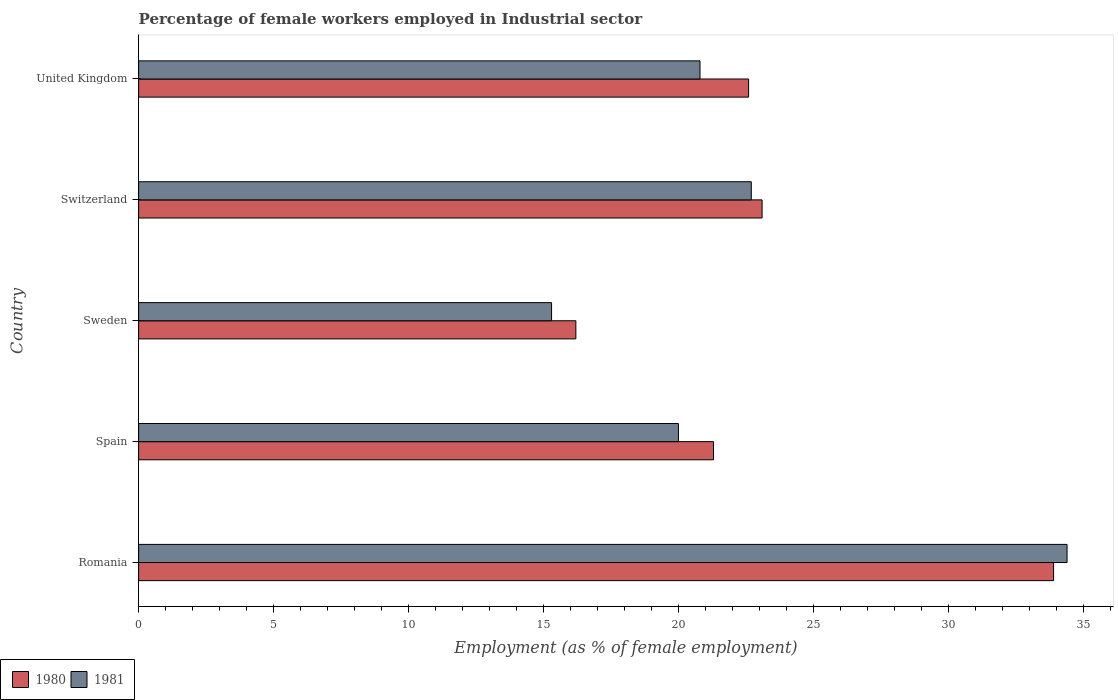Are the number of bars per tick equal to the number of legend labels?
Ensure brevity in your answer.  Yes. Are the number of bars on each tick of the Y-axis equal?
Offer a very short reply. Yes. How many bars are there on the 5th tick from the top?
Offer a terse response. 2. In how many cases, is the number of bars for a given country not equal to the number of legend labels?
Give a very brief answer. 0. What is the percentage of females employed in Industrial sector in 1981 in Romania?
Give a very brief answer. 34.4. Across all countries, what is the maximum percentage of females employed in Industrial sector in 1981?
Your answer should be very brief. 34.4. Across all countries, what is the minimum percentage of females employed in Industrial sector in 1981?
Offer a terse response. 15.3. In which country was the percentage of females employed in Industrial sector in 1980 maximum?
Ensure brevity in your answer.  Romania. What is the total percentage of females employed in Industrial sector in 1981 in the graph?
Your response must be concise. 113.2. What is the difference between the percentage of females employed in Industrial sector in 1981 in Sweden and that in United Kingdom?
Provide a succinct answer. -5.5. What is the difference between the percentage of females employed in Industrial sector in 1980 in Switzerland and the percentage of females employed in Industrial sector in 1981 in Spain?
Provide a short and direct response. 3.1. What is the average percentage of females employed in Industrial sector in 1980 per country?
Your response must be concise. 23.42. What is the difference between the percentage of females employed in Industrial sector in 1981 and percentage of females employed in Industrial sector in 1980 in Sweden?
Give a very brief answer. -0.9. In how many countries, is the percentage of females employed in Industrial sector in 1981 greater than 23 %?
Provide a succinct answer. 1. What is the ratio of the percentage of females employed in Industrial sector in 1981 in Romania to that in United Kingdom?
Make the answer very short. 1.65. Is the percentage of females employed in Industrial sector in 1980 in Sweden less than that in Switzerland?
Offer a very short reply. Yes. What is the difference between the highest and the second highest percentage of females employed in Industrial sector in 1981?
Offer a terse response. 11.7. What is the difference between the highest and the lowest percentage of females employed in Industrial sector in 1981?
Your response must be concise. 19.1. In how many countries, is the percentage of females employed in Industrial sector in 1980 greater than the average percentage of females employed in Industrial sector in 1980 taken over all countries?
Keep it short and to the point. 1. Is the sum of the percentage of females employed in Industrial sector in 1980 in Switzerland and United Kingdom greater than the maximum percentage of females employed in Industrial sector in 1981 across all countries?
Provide a short and direct response. Yes. How many bars are there?
Provide a short and direct response. 10. Are all the bars in the graph horizontal?
Your answer should be very brief. Yes. How many countries are there in the graph?
Your response must be concise. 5. Are the values on the major ticks of X-axis written in scientific E-notation?
Ensure brevity in your answer.  No. Does the graph contain any zero values?
Give a very brief answer. No. Where does the legend appear in the graph?
Offer a very short reply. Bottom left. How many legend labels are there?
Provide a succinct answer. 2. What is the title of the graph?
Provide a succinct answer. Percentage of female workers employed in Industrial sector. Does "1966" appear as one of the legend labels in the graph?
Make the answer very short. No. What is the label or title of the X-axis?
Your response must be concise. Employment (as % of female employment). What is the label or title of the Y-axis?
Offer a very short reply. Country. What is the Employment (as % of female employment) in 1980 in Romania?
Offer a terse response. 33.9. What is the Employment (as % of female employment) in 1981 in Romania?
Provide a succinct answer. 34.4. What is the Employment (as % of female employment) in 1980 in Spain?
Ensure brevity in your answer.  21.3. What is the Employment (as % of female employment) in 1980 in Sweden?
Ensure brevity in your answer.  16.2. What is the Employment (as % of female employment) in 1981 in Sweden?
Your answer should be very brief. 15.3. What is the Employment (as % of female employment) of 1980 in Switzerland?
Keep it short and to the point. 23.1. What is the Employment (as % of female employment) in 1981 in Switzerland?
Offer a terse response. 22.7. What is the Employment (as % of female employment) of 1980 in United Kingdom?
Offer a very short reply. 22.6. What is the Employment (as % of female employment) of 1981 in United Kingdom?
Your answer should be very brief. 20.8. Across all countries, what is the maximum Employment (as % of female employment) in 1980?
Offer a very short reply. 33.9. Across all countries, what is the maximum Employment (as % of female employment) of 1981?
Make the answer very short. 34.4. Across all countries, what is the minimum Employment (as % of female employment) in 1980?
Give a very brief answer. 16.2. Across all countries, what is the minimum Employment (as % of female employment) in 1981?
Offer a terse response. 15.3. What is the total Employment (as % of female employment) in 1980 in the graph?
Make the answer very short. 117.1. What is the total Employment (as % of female employment) in 1981 in the graph?
Give a very brief answer. 113.2. What is the difference between the Employment (as % of female employment) of 1980 in Romania and that in Sweden?
Give a very brief answer. 17.7. What is the difference between the Employment (as % of female employment) of 1980 in Romania and that in Switzerland?
Your response must be concise. 10.8. What is the difference between the Employment (as % of female employment) of 1980 in Romania and that in United Kingdom?
Give a very brief answer. 11.3. What is the difference between the Employment (as % of female employment) in 1981 in Spain and that in Sweden?
Your response must be concise. 4.7. What is the difference between the Employment (as % of female employment) in 1980 in Spain and that in Switzerland?
Keep it short and to the point. -1.8. What is the difference between the Employment (as % of female employment) in 1981 in Spain and that in Switzerland?
Provide a short and direct response. -2.7. What is the difference between the Employment (as % of female employment) of 1980 in Spain and that in United Kingdom?
Your answer should be very brief. -1.3. What is the difference between the Employment (as % of female employment) in 1981 in Sweden and that in Switzerland?
Your answer should be compact. -7.4. What is the difference between the Employment (as % of female employment) of 1981 in Switzerland and that in United Kingdom?
Give a very brief answer. 1.9. What is the difference between the Employment (as % of female employment) of 1980 in Romania and the Employment (as % of female employment) of 1981 in United Kingdom?
Provide a succinct answer. 13.1. What is the difference between the Employment (as % of female employment) of 1980 in Spain and the Employment (as % of female employment) of 1981 in Sweden?
Offer a terse response. 6. What is the difference between the Employment (as % of female employment) of 1980 in Sweden and the Employment (as % of female employment) of 1981 in Switzerland?
Give a very brief answer. -6.5. What is the difference between the Employment (as % of female employment) of 1980 in Switzerland and the Employment (as % of female employment) of 1981 in United Kingdom?
Provide a succinct answer. 2.3. What is the average Employment (as % of female employment) in 1980 per country?
Make the answer very short. 23.42. What is the average Employment (as % of female employment) of 1981 per country?
Your answer should be very brief. 22.64. What is the difference between the Employment (as % of female employment) of 1980 and Employment (as % of female employment) of 1981 in Romania?
Your response must be concise. -0.5. What is the difference between the Employment (as % of female employment) of 1980 and Employment (as % of female employment) of 1981 in Switzerland?
Ensure brevity in your answer.  0.4. What is the difference between the Employment (as % of female employment) in 1980 and Employment (as % of female employment) in 1981 in United Kingdom?
Provide a succinct answer. 1.8. What is the ratio of the Employment (as % of female employment) of 1980 in Romania to that in Spain?
Provide a succinct answer. 1.59. What is the ratio of the Employment (as % of female employment) of 1981 in Romania to that in Spain?
Offer a very short reply. 1.72. What is the ratio of the Employment (as % of female employment) of 1980 in Romania to that in Sweden?
Provide a short and direct response. 2.09. What is the ratio of the Employment (as % of female employment) in 1981 in Romania to that in Sweden?
Provide a short and direct response. 2.25. What is the ratio of the Employment (as % of female employment) in 1980 in Romania to that in Switzerland?
Make the answer very short. 1.47. What is the ratio of the Employment (as % of female employment) of 1981 in Romania to that in Switzerland?
Your answer should be compact. 1.52. What is the ratio of the Employment (as % of female employment) in 1980 in Romania to that in United Kingdom?
Ensure brevity in your answer.  1.5. What is the ratio of the Employment (as % of female employment) in 1981 in Romania to that in United Kingdom?
Your answer should be compact. 1.65. What is the ratio of the Employment (as % of female employment) in 1980 in Spain to that in Sweden?
Your answer should be very brief. 1.31. What is the ratio of the Employment (as % of female employment) of 1981 in Spain to that in Sweden?
Your response must be concise. 1.31. What is the ratio of the Employment (as % of female employment) in 1980 in Spain to that in Switzerland?
Give a very brief answer. 0.92. What is the ratio of the Employment (as % of female employment) of 1981 in Spain to that in Switzerland?
Your response must be concise. 0.88. What is the ratio of the Employment (as % of female employment) of 1980 in Spain to that in United Kingdom?
Give a very brief answer. 0.94. What is the ratio of the Employment (as % of female employment) of 1981 in Spain to that in United Kingdom?
Offer a terse response. 0.96. What is the ratio of the Employment (as % of female employment) of 1980 in Sweden to that in Switzerland?
Your answer should be compact. 0.7. What is the ratio of the Employment (as % of female employment) of 1981 in Sweden to that in Switzerland?
Your answer should be compact. 0.67. What is the ratio of the Employment (as % of female employment) in 1980 in Sweden to that in United Kingdom?
Your answer should be compact. 0.72. What is the ratio of the Employment (as % of female employment) of 1981 in Sweden to that in United Kingdom?
Provide a short and direct response. 0.74. What is the ratio of the Employment (as % of female employment) in 1980 in Switzerland to that in United Kingdom?
Your response must be concise. 1.02. What is the ratio of the Employment (as % of female employment) of 1981 in Switzerland to that in United Kingdom?
Ensure brevity in your answer.  1.09. What is the difference between the highest and the second highest Employment (as % of female employment) in 1980?
Offer a terse response. 10.8. What is the difference between the highest and the lowest Employment (as % of female employment) of 1980?
Make the answer very short. 17.7. 